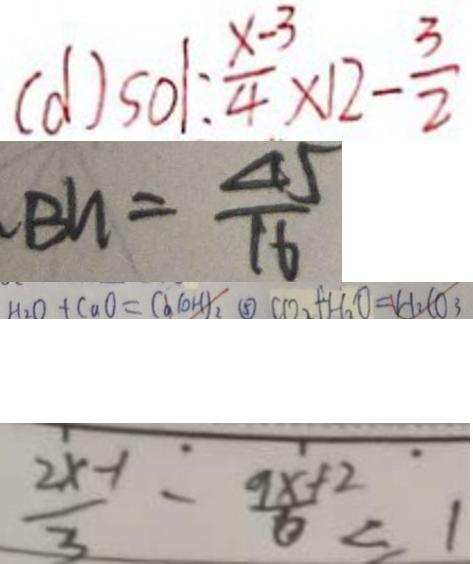<formula> <loc_0><loc_0><loc_500><loc_500>( d ) s o 1 : \frac { x - 3 } { 4 } \times 1 2 - \frac { 3 } { 2 } 
 B n = \frac { 4 5 } { 1 6 } 
 H _ { 2 } O + C a O = C a ( O H ) _ { 2 } \textcircled { 5 } C O _ { 2 } + H _ { 2 } O = H _ { 2 } C O _ { 3 } 
 \frac { 2 x - 1 } { 3 } - \frac { 9 x + 2 } { 6 } < 1</formula> 